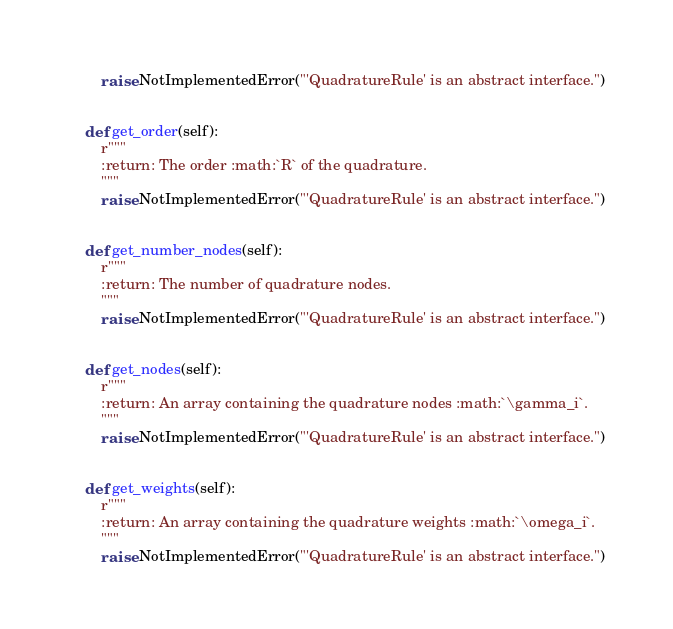Convert code to text. <code><loc_0><loc_0><loc_500><loc_500><_Python_>        raise NotImplementedError("'QuadratureRule' is an abstract interface.")


    def get_order(self):
        r"""
        :return: The order :math:`R` of the quadrature.
        """
        raise NotImplementedError("'QuadratureRule' is an abstract interface.")


    def get_number_nodes(self):
        r"""
        :return: The number of quadrature nodes.
        """
        raise NotImplementedError("'QuadratureRule' is an abstract interface.")


    def get_nodes(self):
        r"""
        :return: An array containing the quadrature nodes :math:`\gamma_i`.
        """
        raise NotImplementedError("'QuadratureRule' is an abstract interface.")


    def get_weights(self):
        r"""
        :return: An array containing the quadrature weights :math:`\omega_i`.
        """
        raise NotImplementedError("'QuadratureRule' is an abstract interface.")
</code> 